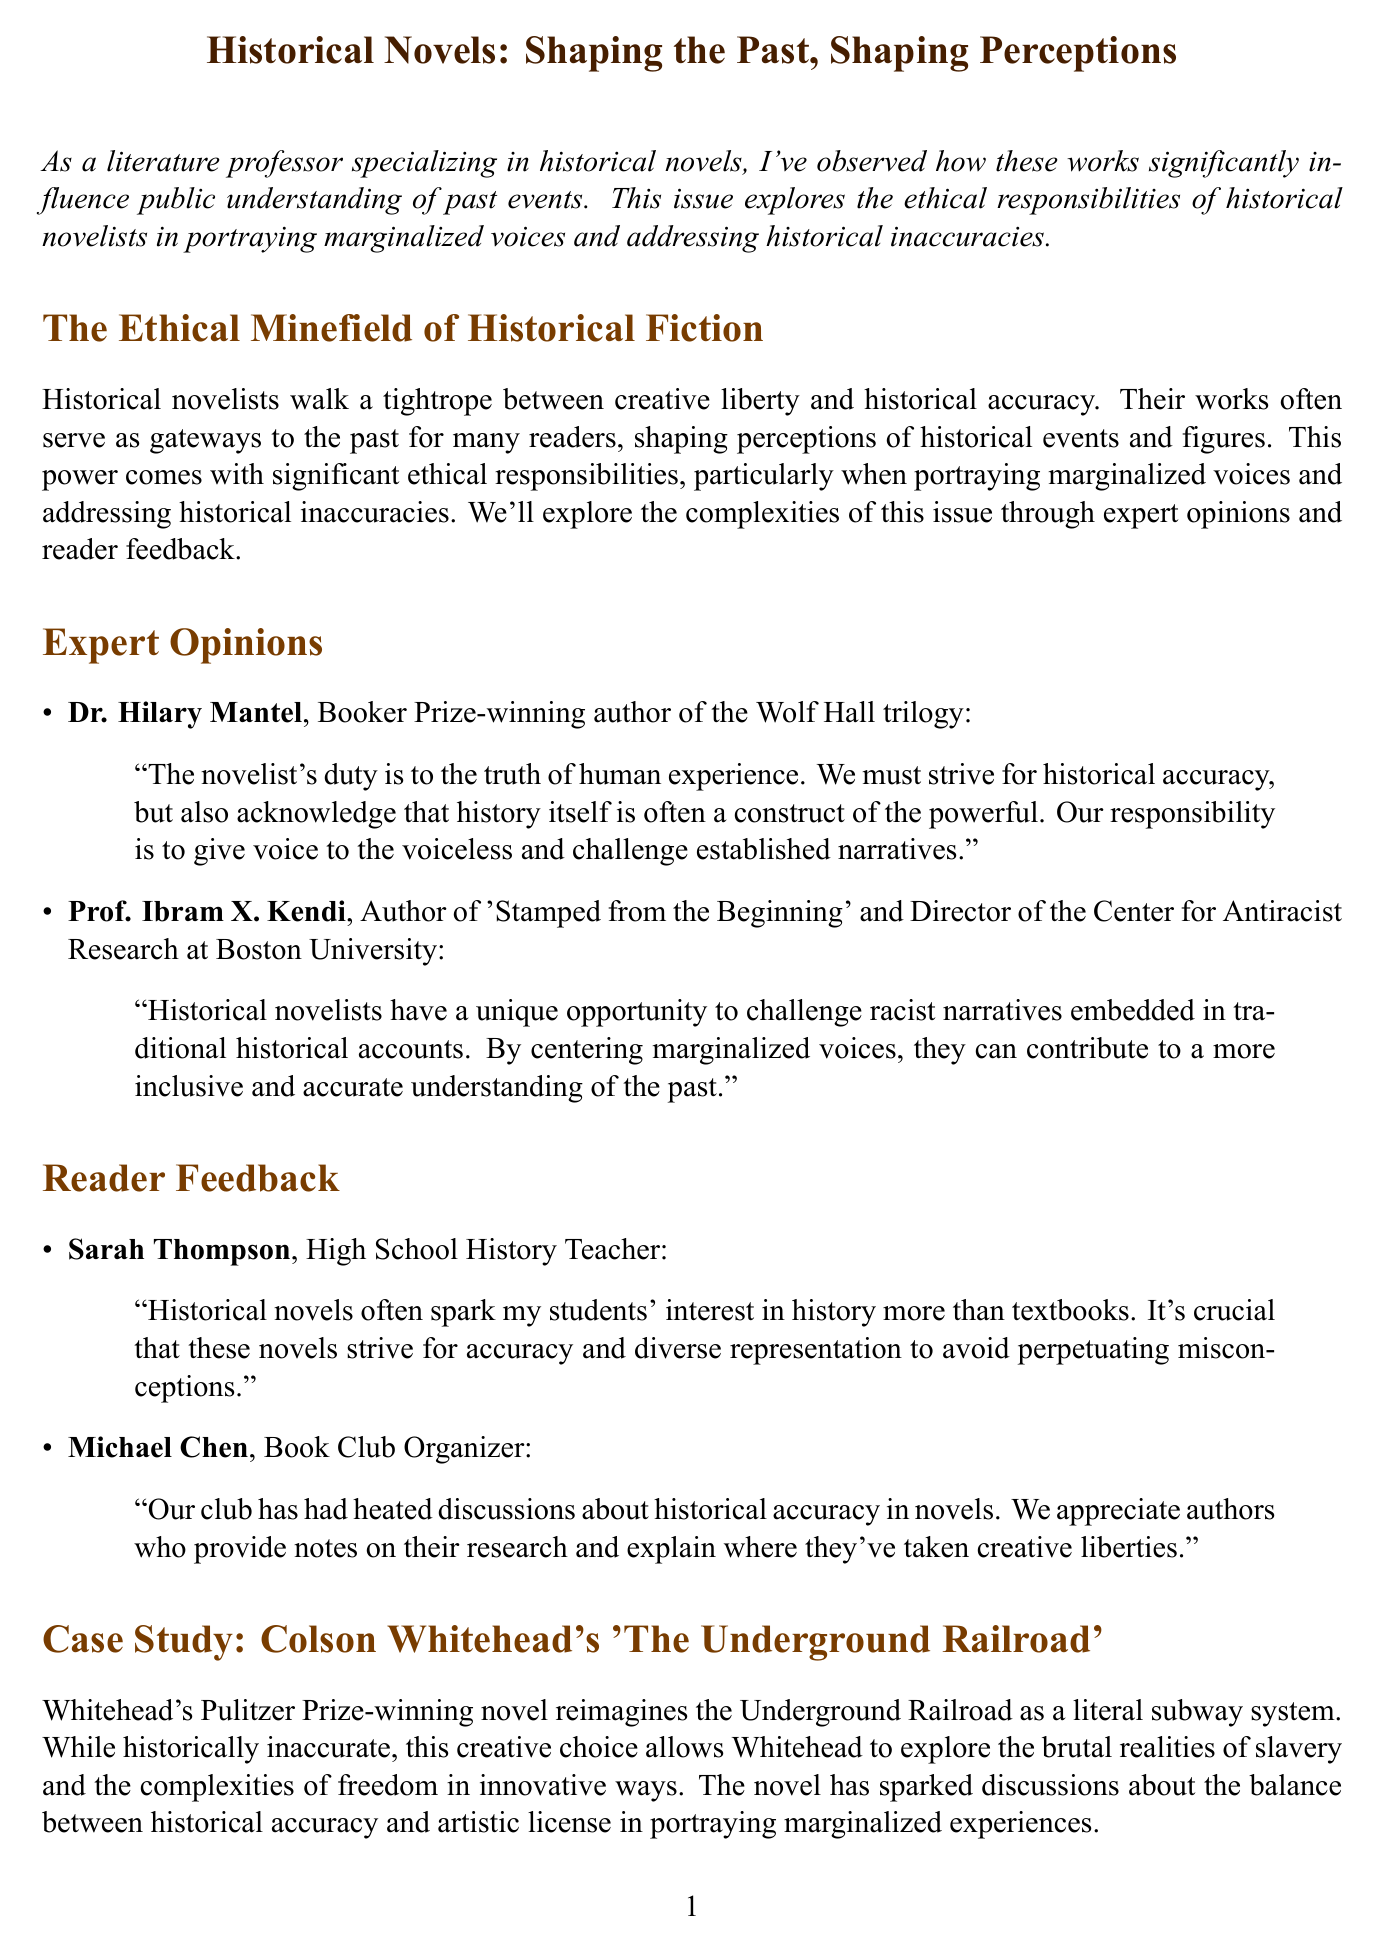What is the title of the newsletter? The title of the newsletter is explicitly stated in the introduction section of the document.
Answer: Historical Novels: Shaping the Past, Shaping Perceptions Who is the author of the case study mentioned? The case study discusses Colson Whitehead, who is identified as the author of the novel in question.
Answer: Colson Whitehead What is Dr. Hilary Mantel's notable achievement? Dr. Hilary Mantel is recognized for winning the Booker Prize, which is stated alongside her name.
Answer: Booker Prize What does Prof. Ibram X. Kendi emphasize in his opinion? Prof. Kendi highlights the importance of centering marginalized voices in historical narratives, which is part of his quoted statement.
Answer: Centering marginalized voices What unique element does Whitehead's novel present? The document notes that Whitehead's novel reimagines the Underground Railroad as a literal subway system, which is a key feature of the case study.
Answer: A literal subway system What is the primary focus of the conclusion section? The conclusion emphasizes the complexities and ethical responsibilities faced by historical novelists.
Answer: Ethical responsibilities How do Sarah Thompson's students generally respond to historical novels? Sarah Thompson indicates that her students often show increased interest in history when exposed to historical novels.
Answer: Increased interest What concept does Prof. Hayden White's theory relate to? The document mentions that Hayden White's concept of 'metahistory' pertains to the interpretation of historical narratives.
Answer: Metahistory 